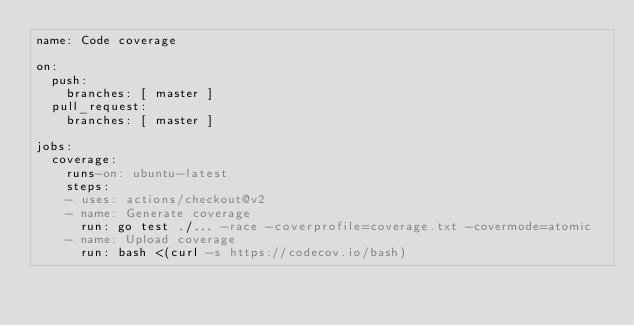<code> <loc_0><loc_0><loc_500><loc_500><_YAML_>name: Code coverage

on:
  push:
    branches: [ master ]
  pull_request:
    branches: [ master ]

jobs:
  coverage:
    runs-on: ubuntu-latest
    steps:
    - uses: actions/checkout@v2
    - name: Generate coverage
      run: go test ./... -race -coverprofile=coverage.txt -covermode=atomic
    - name: Upload coverage
      run: bash <(curl -s https://codecov.io/bash)
</code> 